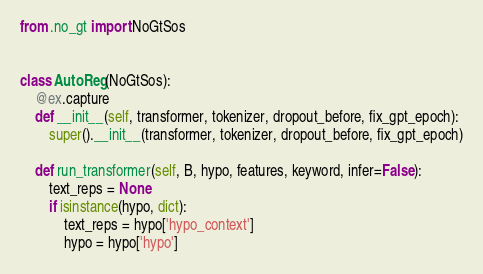<code> <loc_0><loc_0><loc_500><loc_500><_Python_>
from .no_gt import NoGtSos


class AutoReg(NoGtSos):
    @ex.capture
    def __init__(self, transformer, tokenizer, dropout_before, fix_gpt_epoch):
        super().__init__(transformer, tokenizer, dropout_before, fix_gpt_epoch)

    def run_transformer(self, B, hypo, features, keyword, infer=False):
        text_reps = None
        if isinstance(hypo, dict):
            text_reps = hypo['hypo_context']
            hypo = hypo['hypo']</code> 